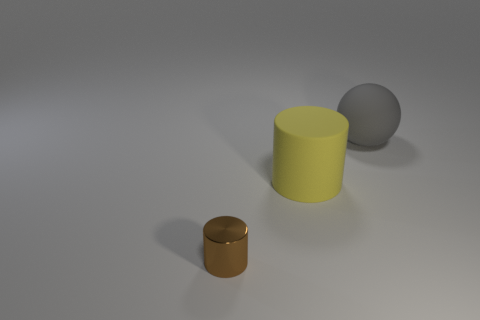Is there any other thing that is the same material as the small brown cylinder?
Ensure brevity in your answer.  No. There is a cylinder to the right of the shiny cylinder; is its size the same as the cylinder in front of the big yellow rubber cylinder?
Your response must be concise. No. Is the number of large matte objects that are to the left of the large gray rubber sphere greater than the number of large things to the left of the yellow cylinder?
Make the answer very short. Yes. Are there any cyan cylinders that have the same material as the small brown thing?
Offer a very short reply. No. What color is the big sphere?
Your answer should be compact. Gray. How many brown metal objects have the same shape as the yellow object?
Give a very brief answer. 1. Is the object on the right side of the yellow rubber cylinder made of the same material as the cylinder on the right side of the tiny brown metal cylinder?
Your answer should be compact. Yes. There is a object in front of the matte thing that is in front of the gray sphere; how big is it?
Give a very brief answer. Small. Is there anything else that is the same size as the brown cylinder?
Make the answer very short. No. There is a tiny brown object that is the same shape as the big yellow rubber object; what is it made of?
Give a very brief answer. Metal. 